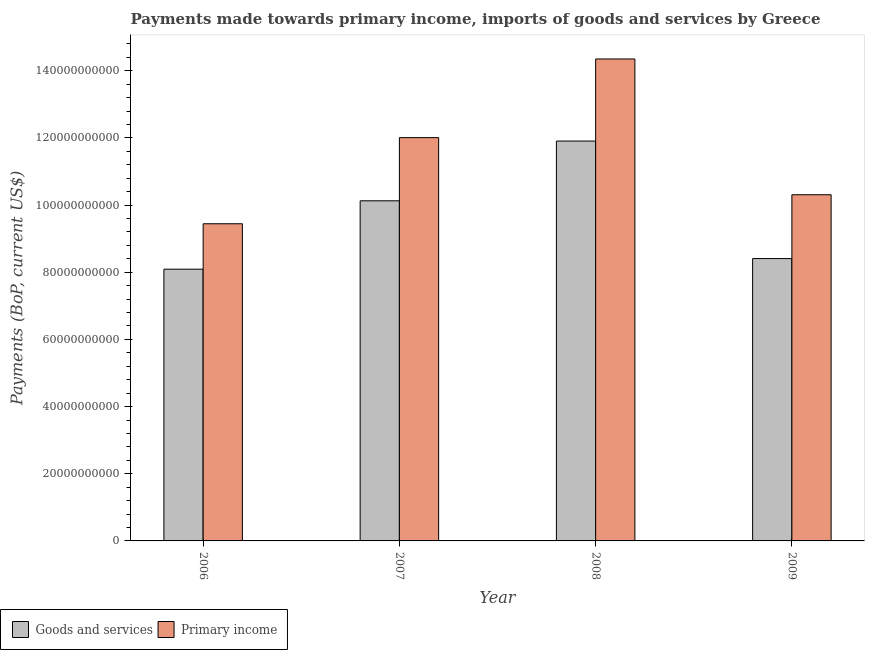Are the number of bars per tick equal to the number of legend labels?
Make the answer very short. Yes. What is the label of the 1st group of bars from the left?
Your answer should be compact. 2006. In how many cases, is the number of bars for a given year not equal to the number of legend labels?
Provide a succinct answer. 0. What is the payments made towards primary income in 2008?
Ensure brevity in your answer.  1.44e+11. Across all years, what is the maximum payments made towards goods and services?
Keep it short and to the point. 1.19e+11. Across all years, what is the minimum payments made towards primary income?
Your answer should be very brief. 9.44e+1. In which year was the payments made towards primary income minimum?
Give a very brief answer. 2006. What is the total payments made towards goods and services in the graph?
Keep it short and to the point. 3.85e+11. What is the difference between the payments made towards goods and services in 2006 and that in 2008?
Give a very brief answer. -3.81e+1. What is the difference between the payments made towards primary income in 2008 and the payments made towards goods and services in 2007?
Ensure brevity in your answer.  2.34e+1. What is the average payments made towards goods and services per year?
Your answer should be very brief. 9.63e+1. In the year 2008, what is the difference between the payments made towards primary income and payments made towards goods and services?
Ensure brevity in your answer.  0. In how many years, is the payments made towards goods and services greater than 84000000000 US$?
Your answer should be compact. 3. What is the ratio of the payments made towards primary income in 2007 to that in 2009?
Keep it short and to the point. 1.17. Is the difference between the payments made towards goods and services in 2006 and 2009 greater than the difference between the payments made towards primary income in 2006 and 2009?
Ensure brevity in your answer.  No. What is the difference between the highest and the second highest payments made towards primary income?
Your answer should be compact. 2.34e+1. What is the difference between the highest and the lowest payments made towards primary income?
Make the answer very short. 4.91e+1. Is the sum of the payments made towards goods and services in 2008 and 2009 greater than the maximum payments made towards primary income across all years?
Your answer should be very brief. Yes. What does the 1st bar from the left in 2007 represents?
Offer a very short reply. Goods and services. What does the 1st bar from the right in 2008 represents?
Give a very brief answer. Primary income. How many bars are there?
Your response must be concise. 8. What is the difference between two consecutive major ticks on the Y-axis?
Provide a short and direct response. 2.00e+1. Does the graph contain any zero values?
Make the answer very short. No. How are the legend labels stacked?
Your answer should be compact. Horizontal. What is the title of the graph?
Offer a terse response. Payments made towards primary income, imports of goods and services by Greece. Does "Savings" appear as one of the legend labels in the graph?
Ensure brevity in your answer.  No. What is the label or title of the X-axis?
Your answer should be compact. Year. What is the label or title of the Y-axis?
Your answer should be compact. Payments (BoP, current US$). What is the Payments (BoP, current US$) in Goods and services in 2006?
Your answer should be compact. 8.09e+1. What is the Payments (BoP, current US$) in Primary income in 2006?
Make the answer very short. 9.44e+1. What is the Payments (BoP, current US$) in Goods and services in 2007?
Your answer should be very brief. 1.01e+11. What is the Payments (BoP, current US$) of Primary income in 2007?
Your response must be concise. 1.20e+11. What is the Payments (BoP, current US$) in Goods and services in 2008?
Keep it short and to the point. 1.19e+11. What is the Payments (BoP, current US$) in Primary income in 2008?
Ensure brevity in your answer.  1.44e+11. What is the Payments (BoP, current US$) of Goods and services in 2009?
Provide a succinct answer. 8.41e+1. What is the Payments (BoP, current US$) in Primary income in 2009?
Provide a short and direct response. 1.03e+11. Across all years, what is the maximum Payments (BoP, current US$) of Goods and services?
Provide a short and direct response. 1.19e+11. Across all years, what is the maximum Payments (BoP, current US$) of Primary income?
Give a very brief answer. 1.44e+11. Across all years, what is the minimum Payments (BoP, current US$) of Goods and services?
Give a very brief answer. 8.09e+1. Across all years, what is the minimum Payments (BoP, current US$) of Primary income?
Make the answer very short. 9.44e+1. What is the total Payments (BoP, current US$) of Goods and services in the graph?
Your answer should be compact. 3.85e+11. What is the total Payments (BoP, current US$) in Primary income in the graph?
Your answer should be very brief. 4.61e+11. What is the difference between the Payments (BoP, current US$) in Goods and services in 2006 and that in 2007?
Ensure brevity in your answer.  -2.04e+1. What is the difference between the Payments (BoP, current US$) in Primary income in 2006 and that in 2007?
Offer a terse response. -2.56e+1. What is the difference between the Payments (BoP, current US$) in Goods and services in 2006 and that in 2008?
Your answer should be very brief. -3.81e+1. What is the difference between the Payments (BoP, current US$) in Primary income in 2006 and that in 2008?
Make the answer very short. -4.91e+1. What is the difference between the Payments (BoP, current US$) in Goods and services in 2006 and that in 2009?
Give a very brief answer. -3.16e+09. What is the difference between the Payments (BoP, current US$) of Primary income in 2006 and that in 2009?
Provide a succinct answer. -8.64e+09. What is the difference between the Payments (BoP, current US$) of Goods and services in 2007 and that in 2008?
Provide a succinct answer. -1.78e+1. What is the difference between the Payments (BoP, current US$) in Primary income in 2007 and that in 2008?
Your answer should be very brief. -2.34e+1. What is the difference between the Payments (BoP, current US$) of Goods and services in 2007 and that in 2009?
Ensure brevity in your answer.  1.72e+1. What is the difference between the Payments (BoP, current US$) of Primary income in 2007 and that in 2009?
Provide a succinct answer. 1.70e+1. What is the difference between the Payments (BoP, current US$) of Goods and services in 2008 and that in 2009?
Offer a very short reply. 3.50e+1. What is the difference between the Payments (BoP, current US$) in Primary income in 2008 and that in 2009?
Offer a very short reply. 4.04e+1. What is the difference between the Payments (BoP, current US$) of Goods and services in 2006 and the Payments (BoP, current US$) of Primary income in 2007?
Keep it short and to the point. -3.92e+1. What is the difference between the Payments (BoP, current US$) in Goods and services in 2006 and the Payments (BoP, current US$) in Primary income in 2008?
Offer a very short reply. -6.26e+1. What is the difference between the Payments (BoP, current US$) in Goods and services in 2006 and the Payments (BoP, current US$) in Primary income in 2009?
Provide a short and direct response. -2.22e+1. What is the difference between the Payments (BoP, current US$) in Goods and services in 2007 and the Payments (BoP, current US$) in Primary income in 2008?
Ensure brevity in your answer.  -4.22e+1. What is the difference between the Payments (BoP, current US$) of Goods and services in 2007 and the Payments (BoP, current US$) of Primary income in 2009?
Offer a very short reply. -1.80e+09. What is the difference between the Payments (BoP, current US$) of Goods and services in 2008 and the Payments (BoP, current US$) of Primary income in 2009?
Your answer should be very brief. 1.60e+1. What is the average Payments (BoP, current US$) in Goods and services per year?
Provide a succinct answer. 9.63e+1. What is the average Payments (BoP, current US$) in Primary income per year?
Make the answer very short. 1.15e+11. In the year 2006, what is the difference between the Payments (BoP, current US$) of Goods and services and Payments (BoP, current US$) of Primary income?
Make the answer very short. -1.35e+1. In the year 2007, what is the difference between the Payments (BoP, current US$) in Goods and services and Payments (BoP, current US$) in Primary income?
Offer a terse response. -1.88e+1. In the year 2008, what is the difference between the Payments (BoP, current US$) in Goods and services and Payments (BoP, current US$) in Primary income?
Give a very brief answer. -2.44e+1. In the year 2009, what is the difference between the Payments (BoP, current US$) in Goods and services and Payments (BoP, current US$) in Primary income?
Keep it short and to the point. -1.90e+1. What is the ratio of the Payments (BoP, current US$) in Goods and services in 2006 to that in 2007?
Provide a succinct answer. 0.8. What is the ratio of the Payments (BoP, current US$) of Primary income in 2006 to that in 2007?
Give a very brief answer. 0.79. What is the ratio of the Payments (BoP, current US$) in Goods and services in 2006 to that in 2008?
Provide a short and direct response. 0.68. What is the ratio of the Payments (BoP, current US$) in Primary income in 2006 to that in 2008?
Your answer should be compact. 0.66. What is the ratio of the Payments (BoP, current US$) of Goods and services in 2006 to that in 2009?
Keep it short and to the point. 0.96. What is the ratio of the Payments (BoP, current US$) of Primary income in 2006 to that in 2009?
Make the answer very short. 0.92. What is the ratio of the Payments (BoP, current US$) in Goods and services in 2007 to that in 2008?
Keep it short and to the point. 0.85. What is the ratio of the Payments (BoP, current US$) of Primary income in 2007 to that in 2008?
Keep it short and to the point. 0.84. What is the ratio of the Payments (BoP, current US$) in Goods and services in 2007 to that in 2009?
Your answer should be compact. 1.2. What is the ratio of the Payments (BoP, current US$) of Primary income in 2007 to that in 2009?
Your answer should be compact. 1.17. What is the ratio of the Payments (BoP, current US$) of Goods and services in 2008 to that in 2009?
Your answer should be very brief. 1.42. What is the ratio of the Payments (BoP, current US$) in Primary income in 2008 to that in 2009?
Your answer should be compact. 1.39. What is the difference between the highest and the second highest Payments (BoP, current US$) in Goods and services?
Make the answer very short. 1.78e+1. What is the difference between the highest and the second highest Payments (BoP, current US$) in Primary income?
Offer a very short reply. 2.34e+1. What is the difference between the highest and the lowest Payments (BoP, current US$) of Goods and services?
Your response must be concise. 3.81e+1. What is the difference between the highest and the lowest Payments (BoP, current US$) of Primary income?
Provide a succinct answer. 4.91e+1. 